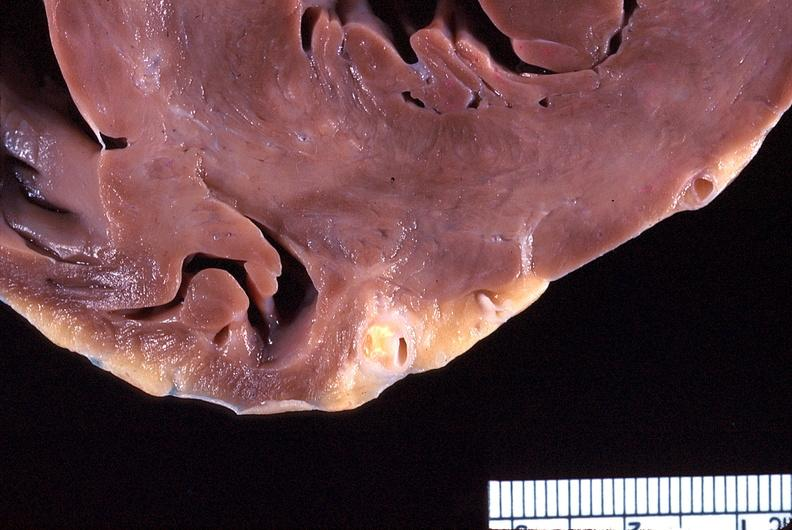where is this?
Answer the question using a single word or phrase. Heart 